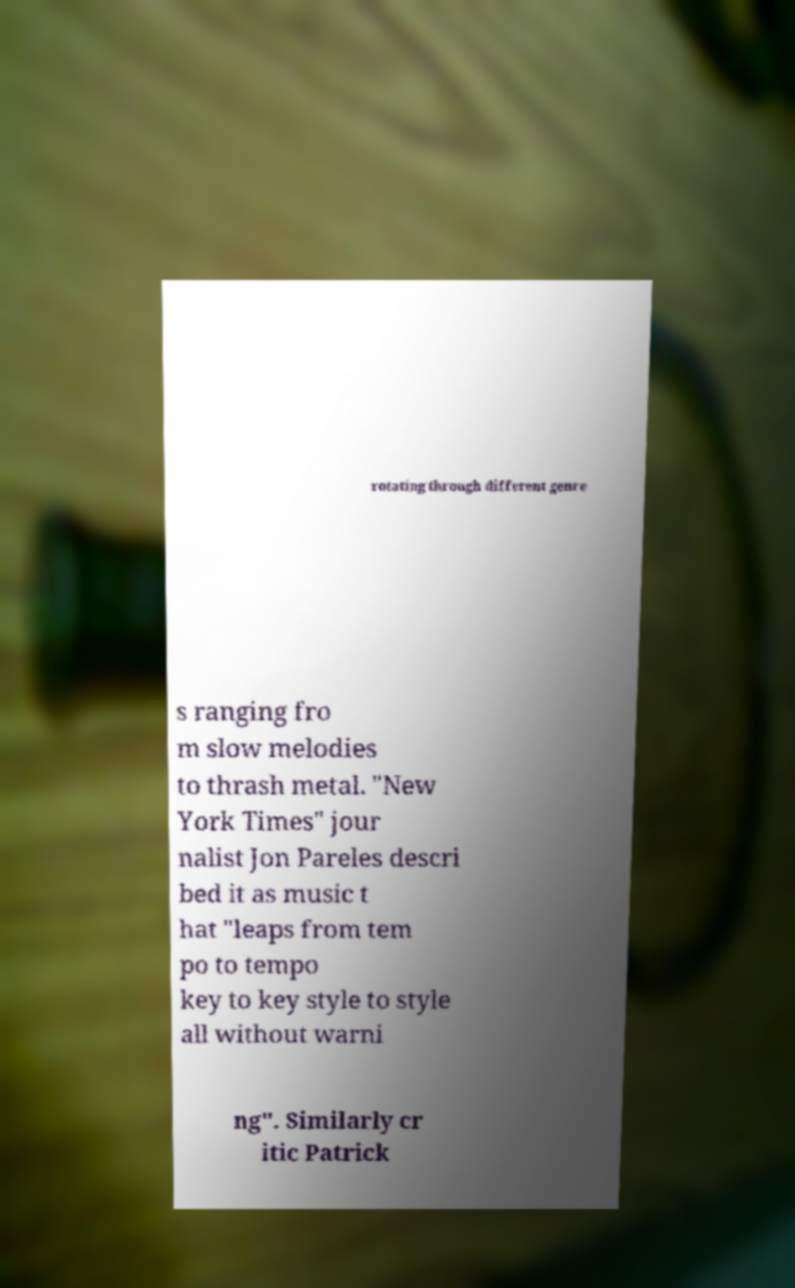Can you read and provide the text displayed in the image?This photo seems to have some interesting text. Can you extract and type it out for me? rotating through different genre s ranging fro m slow melodies to thrash metal. "New York Times" jour nalist Jon Pareles descri bed it as music t hat "leaps from tem po to tempo key to key style to style all without warni ng". Similarly cr itic Patrick 